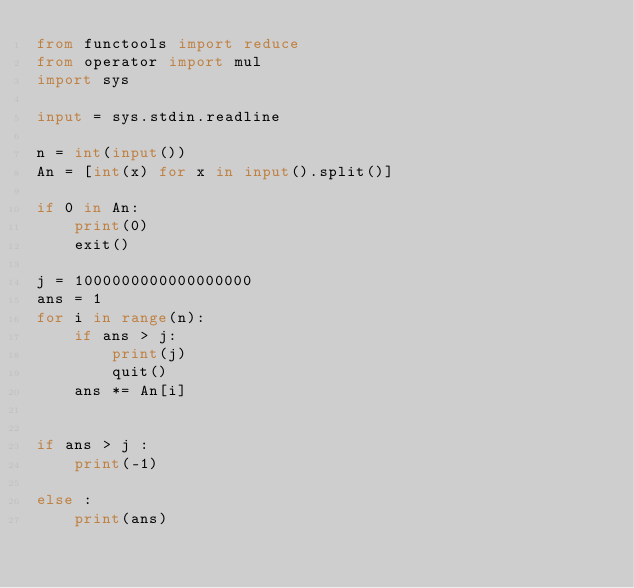<code> <loc_0><loc_0><loc_500><loc_500><_Python_>from functools import reduce
from operator import mul
import sys

input = sys.stdin.readline

n = int(input())
An = [int(x) for x in input().split()]

if 0 in An:
    print(0)
    exit()

j = 1000000000000000000
ans = 1
for i in range(n):
    if ans > j:
        print(j)
        quit()
    ans *= An[i]


if ans > j :
    print(-1)
    
else :
    print(ans)

</code> 